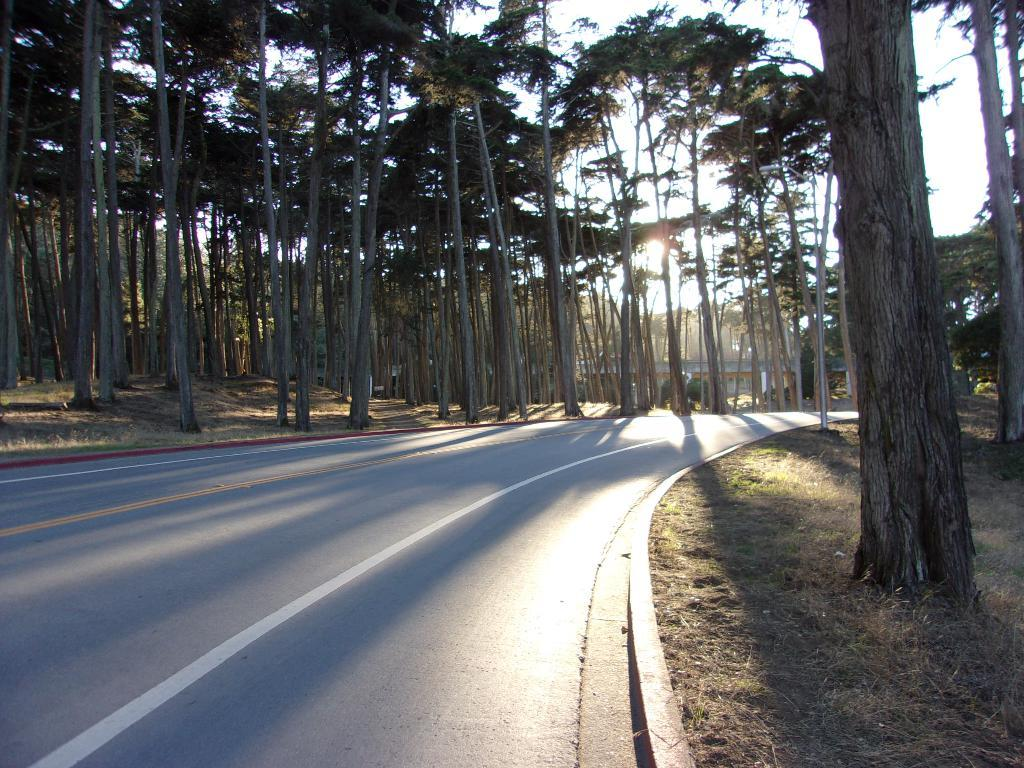What is the main feature of the image? There is a road in the image. What can be seen in the background of the image? There are trees in the background of the image. What is the color of the trees? The trees are green in color. What else is visible in the image? The sky is visible in the image. What is the color of the sky? The sky is white in color. What type of behavior does the cook exhibit while preparing the meal in the image? There is no cook or meal preparation present in the image. 